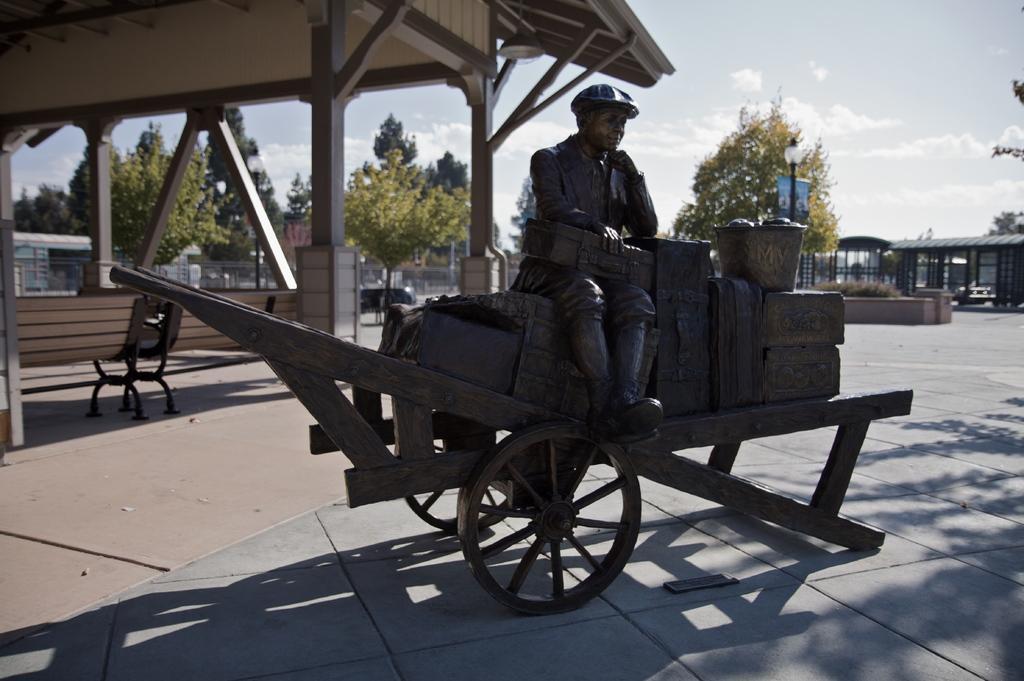Can you describe this image briefly? In the image there is a statue of man sitting on luggage on carriage, behind there is a shed with trees in the background all over the place and above its sky with clouds. 